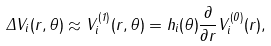Convert formula to latex. <formula><loc_0><loc_0><loc_500><loc_500>\Delta V _ { i } ( r , \theta ) \approx V _ { i } ^ { ( 1 ) } ( r , \theta ) = h _ { i } ( \theta ) \frac { \partial } { \partial r } V _ { i } ^ { ( 0 ) } ( r ) ,</formula> 